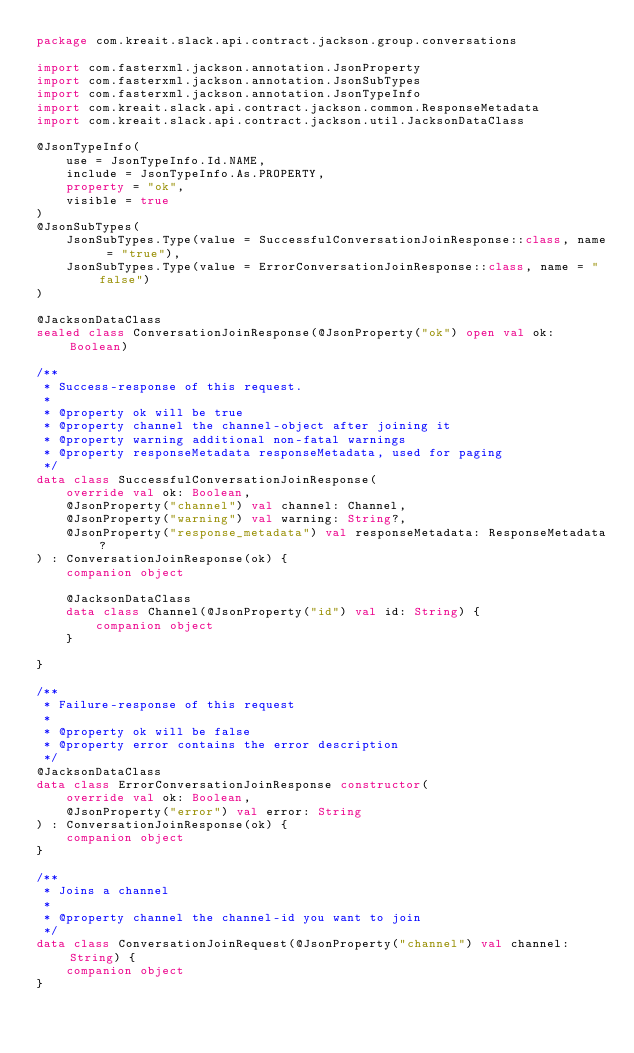<code> <loc_0><loc_0><loc_500><loc_500><_Kotlin_>package com.kreait.slack.api.contract.jackson.group.conversations

import com.fasterxml.jackson.annotation.JsonProperty
import com.fasterxml.jackson.annotation.JsonSubTypes
import com.fasterxml.jackson.annotation.JsonTypeInfo
import com.kreait.slack.api.contract.jackson.common.ResponseMetadata
import com.kreait.slack.api.contract.jackson.util.JacksonDataClass

@JsonTypeInfo(
    use = JsonTypeInfo.Id.NAME,
    include = JsonTypeInfo.As.PROPERTY,
    property = "ok",
    visible = true
)
@JsonSubTypes(
    JsonSubTypes.Type(value = SuccessfulConversationJoinResponse::class, name = "true"),
    JsonSubTypes.Type(value = ErrorConversationJoinResponse::class, name = "false")
)

@JacksonDataClass
sealed class ConversationJoinResponse(@JsonProperty("ok") open val ok: Boolean)

/**
 * Success-response of this request.
 *
 * @property ok will be true
 * @property channel the channel-object after joining it
 * @property warning additional non-fatal warnings
 * @property responseMetadata responseMetadata, used for paging
 */
data class SuccessfulConversationJoinResponse(
    override val ok: Boolean,
    @JsonProperty("channel") val channel: Channel,
    @JsonProperty("warning") val warning: String?,
    @JsonProperty("response_metadata") val responseMetadata: ResponseMetadata?
) : ConversationJoinResponse(ok) {
    companion object

    @JacksonDataClass
    data class Channel(@JsonProperty("id") val id: String) {
        companion object
    }

}

/**
 * Failure-response of this request
 *
 * @property ok will be false
 * @property error contains the error description
 */
@JacksonDataClass
data class ErrorConversationJoinResponse constructor(
    override val ok: Boolean,
    @JsonProperty("error") val error: String
) : ConversationJoinResponse(ok) {
    companion object
}

/**
 * Joins a channel
 *
 * @property channel the channel-id you want to join
 */
data class ConversationJoinRequest(@JsonProperty("channel") val channel: String) {
    companion object
}
</code> 